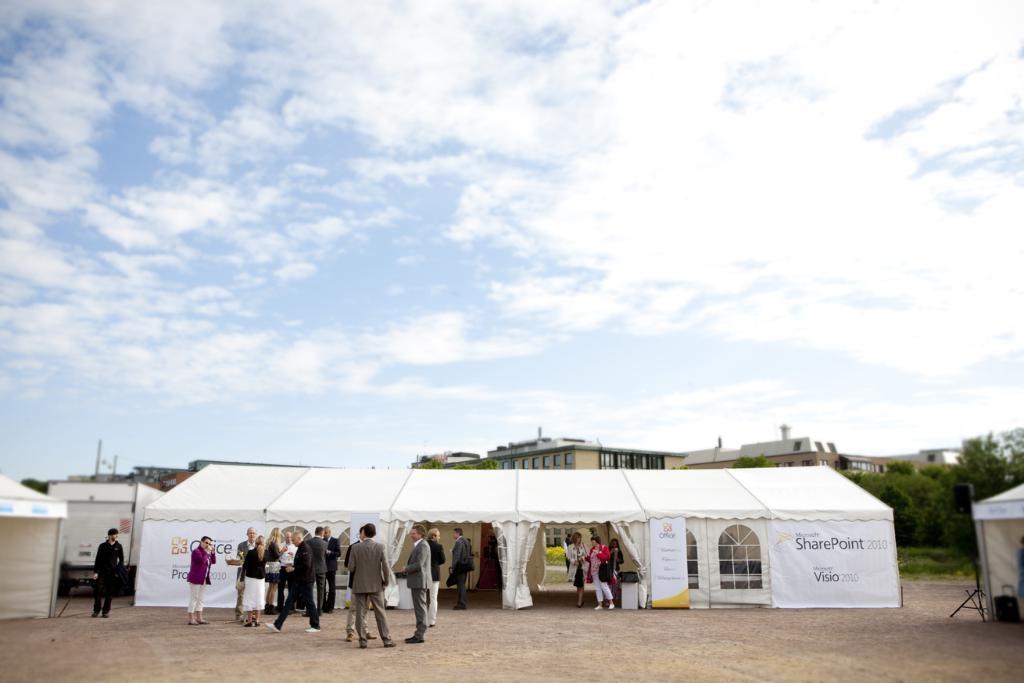How would you summarize this image in a sentence or two? In this picture we can observe white color tint. There are some posters on this tent. We can observe some people standing on the land. In the background there are buildings and trees. There is a sky with some clouds. 